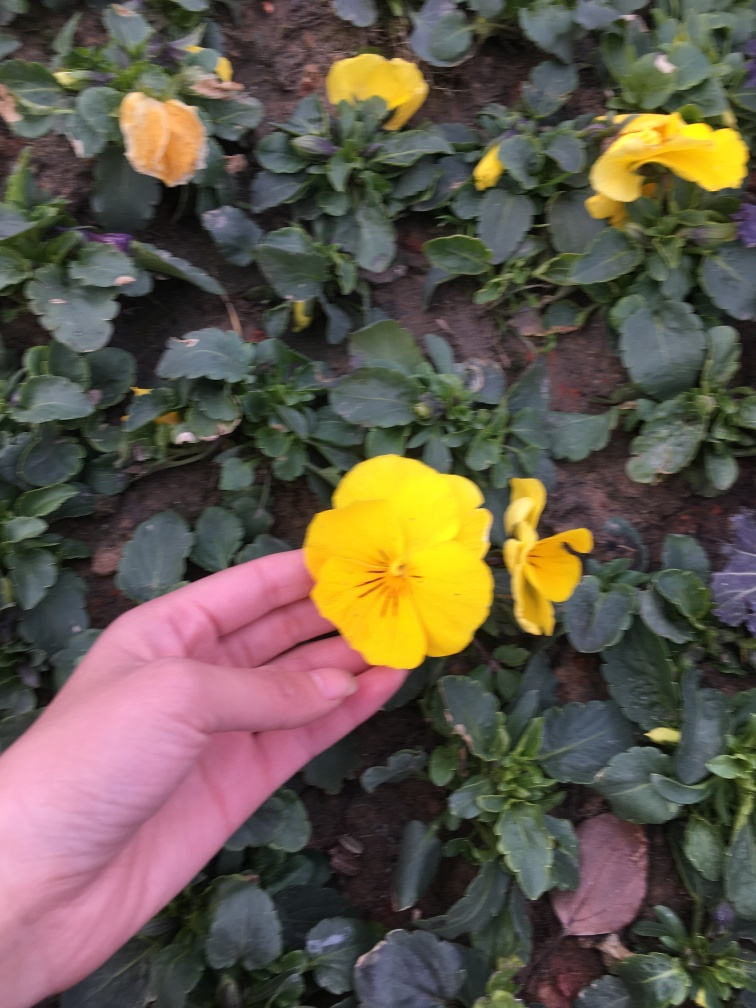What is the quality of the captured subject?
A. Excellent
B. Average
C. Outstanding The quality of the captured subject is average. The photo features a yellow flower held by a hand; however, it seems slightly out of focus and underexposed. The lighting conditions may not have been ideal, as the surrounding flowers appear to have more vibrant colors that are not as distinctly captured in this image. 